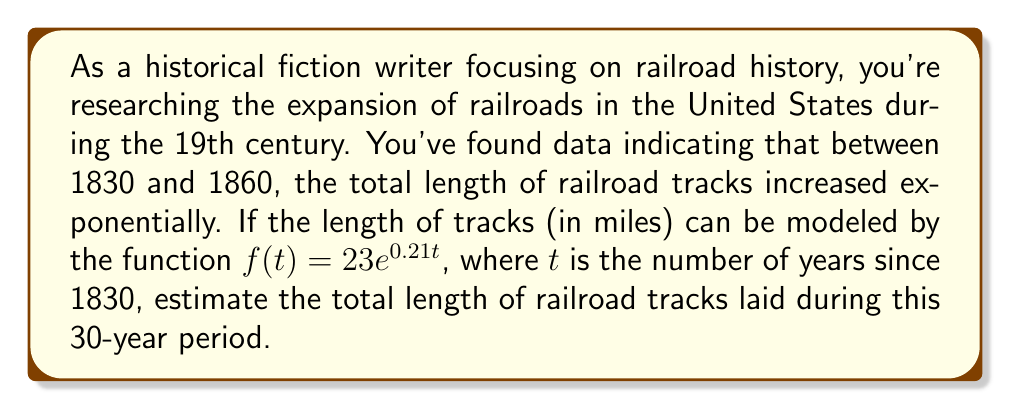Could you help me with this problem? To solve this problem, we need to follow these steps:

1) The function $f(t) = 23e^{0.21t}$ gives us the total length of tracks at any time $t$.

2) We need to find the difference between the length at the end of the period (1860) and the beginning (1830).

3) For 1830, $t = 0$:
   $f(0) = 23e^{0.21 \cdot 0} = 23$ miles

4) For 1860, $t = 30$:
   $f(30) = 23e^{0.21 \cdot 30} = 23e^{6.3} \approx 23 \cdot 544.57 \approx 12,525$ miles

5) The total length of tracks laid during this period is the difference:

   $\text{Length laid} = f(30) - f(0) = 12,525 - 23 = 12,502$ miles

Therefore, approximately 12,502 miles of railroad tracks were laid between 1830 and 1860.
Answer: Approximately 12,502 miles of railroad tracks were laid between 1830 and 1860. 